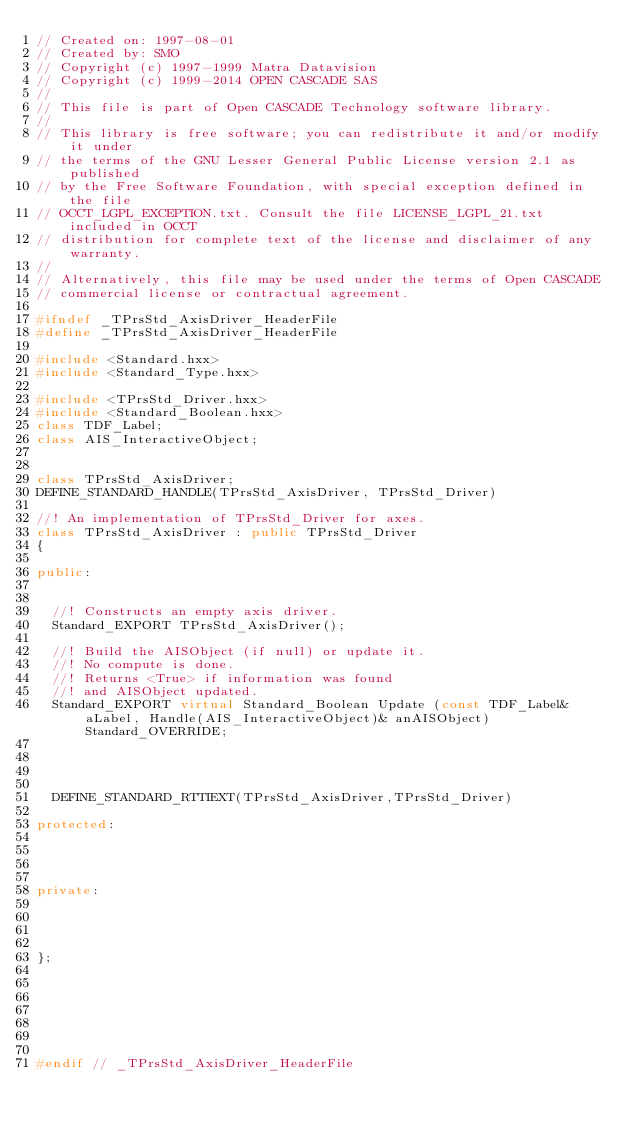Convert code to text. <code><loc_0><loc_0><loc_500><loc_500><_C++_>// Created on: 1997-08-01
// Created by: SMO
// Copyright (c) 1997-1999 Matra Datavision
// Copyright (c) 1999-2014 OPEN CASCADE SAS
//
// This file is part of Open CASCADE Technology software library.
//
// This library is free software; you can redistribute it and/or modify it under
// the terms of the GNU Lesser General Public License version 2.1 as published
// by the Free Software Foundation, with special exception defined in the file
// OCCT_LGPL_EXCEPTION.txt. Consult the file LICENSE_LGPL_21.txt included in OCCT
// distribution for complete text of the license and disclaimer of any warranty.
//
// Alternatively, this file may be used under the terms of Open CASCADE
// commercial license or contractual agreement.

#ifndef _TPrsStd_AxisDriver_HeaderFile
#define _TPrsStd_AxisDriver_HeaderFile

#include <Standard.hxx>
#include <Standard_Type.hxx>

#include <TPrsStd_Driver.hxx>
#include <Standard_Boolean.hxx>
class TDF_Label;
class AIS_InteractiveObject;


class TPrsStd_AxisDriver;
DEFINE_STANDARD_HANDLE(TPrsStd_AxisDriver, TPrsStd_Driver)

//! An implementation of TPrsStd_Driver for axes.
class TPrsStd_AxisDriver : public TPrsStd_Driver
{

public:

  
  //! Constructs an empty axis driver.
  Standard_EXPORT TPrsStd_AxisDriver();
  
  //! Build the AISObject (if null) or update it.
  //! No compute is done.
  //! Returns <True> if information was found
  //! and AISObject updated.
  Standard_EXPORT virtual Standard_Boolean Update (const TDF_Label& aLabel, Handle(AIS_InteractiveObject)& anAISObject) Standard_OVERRIDE;




  DEFINE_STANDARD_RTTIEXT(TPrsStd_AxisDriver,TPrsStd_Driver)

protected:




private:




};







#endif // _TPrsStd_AxisDriver_HeaderFile
</code> 